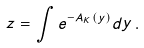<formula> <loc_0><loc_0><loc_500><loc_500>z = \int e ^ { - A _ { K } ( y ) } d y \, .</formula> 